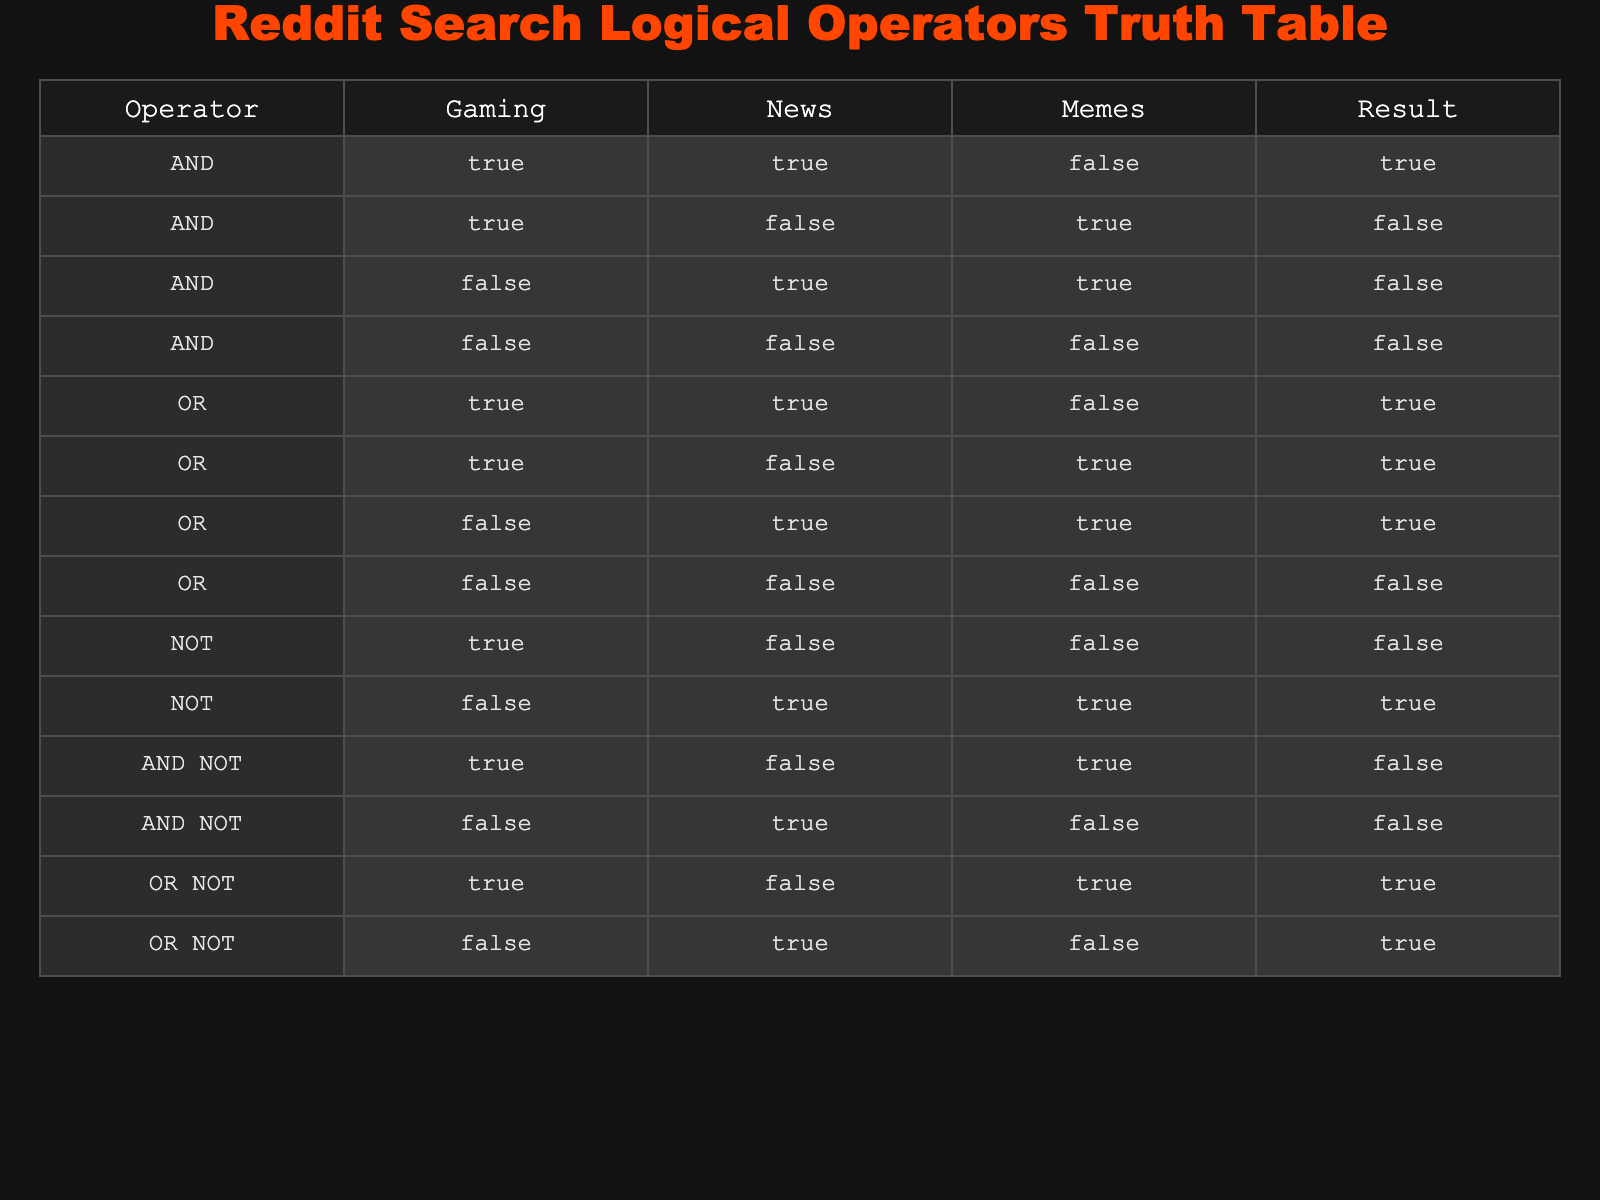What is the result when combining Gaming and News with AND? In the table, for the combination of Gaming and News using the AND operator, we have TRUE and TRUE, which indicates both conditions are satisfied. Thus, the result under the AND operator is TRUE.
Answer: TRUE What happens if you use NOT on Gaming? Looking at the NOT operator, when it is applied to Gaming (which is TRUE), it results in FALSE. Hence, NOT Gaming gives FALSE.
Answer: FALSE How many combinations give a TRUE result using OR? By inspecting the OR operator rows, the result is TRUE for three combinations: both Gaming and News, Gaming with Memes, and only News with Memes. Thus, there are three combinations that give TRUE.
Answer: 3 Is it possible to get FALSE when using the OR NOT operator? Analyzing the rows for the OR NOT operator, it shows that the only instance with FALSE happens when both conditions are FALSE, specifically, OR NOT with FALSE and FALSE combination results in FALSE.
Answer: Yes If we combine Gaming with Memes using AND NOT, will the result be TRUE? In the AND NOT row where Gaming is TRUE and Memes is TRUE, the condition evaluates to FALSE because AND NOT requires the first condition to be true while the second must be false. Since both are true, the result is FALSE.
Answer: No What is the relationship between the AND operator and the result when all conditions are FALSE? In the AND operator, when all conditions (Gaming, News, Memes) are FALSE, the result is FALSE. This showcases that the AND operator only produces TRUE when all inputs are TRUE.
Answer: TRUE How many total TRUE results are there when using NOT across all categories? Whenever applying the NOT operator, there are two instances that yield TRUE: NOT FALSE in News and NOT TRUE in Gaming (which gives FALSE). Hence, there are two TRUE results when NOT is applied across all categories.
Answer: 2 Is combining Gaming as TRUE and Memes as TRUE with AND give different results from combining Gaming as TRUE and News as FALSE using AND? Under the AND operation for the first scenario (TRUE and TRUE), the result is TRUE and for the second scenario (TRUE and FALSE), the result is FALSE. Therefore, the two combinations yield different outcomes.
Answer: Yes 